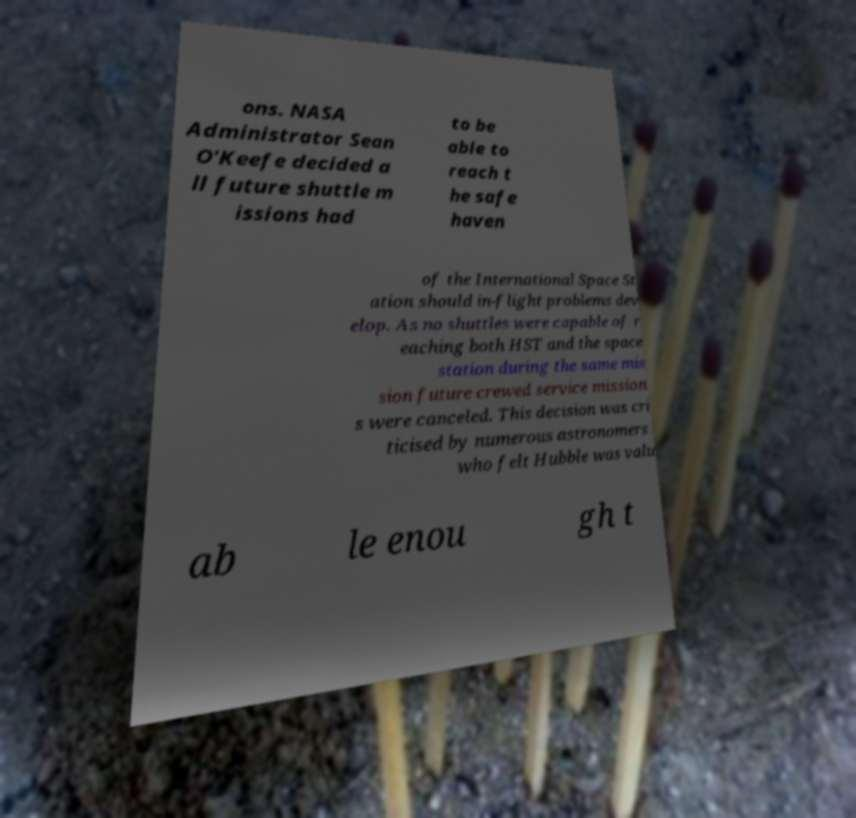Please read and relay the text visible in this image. What does it say? ons. NASA Administrator Sean O'Keefe decided a ll future shuttle m issions had to be able to reach t he safe haven of the International Space St ation should in-flight problems dev elop. As no shuttles were capable of r eaching both HST and the space station during the same mis sion future crewed service mission s were canceled. This decision was cri ticised by numerous astronomers who felt Hubble was valu ab le enou gh t 